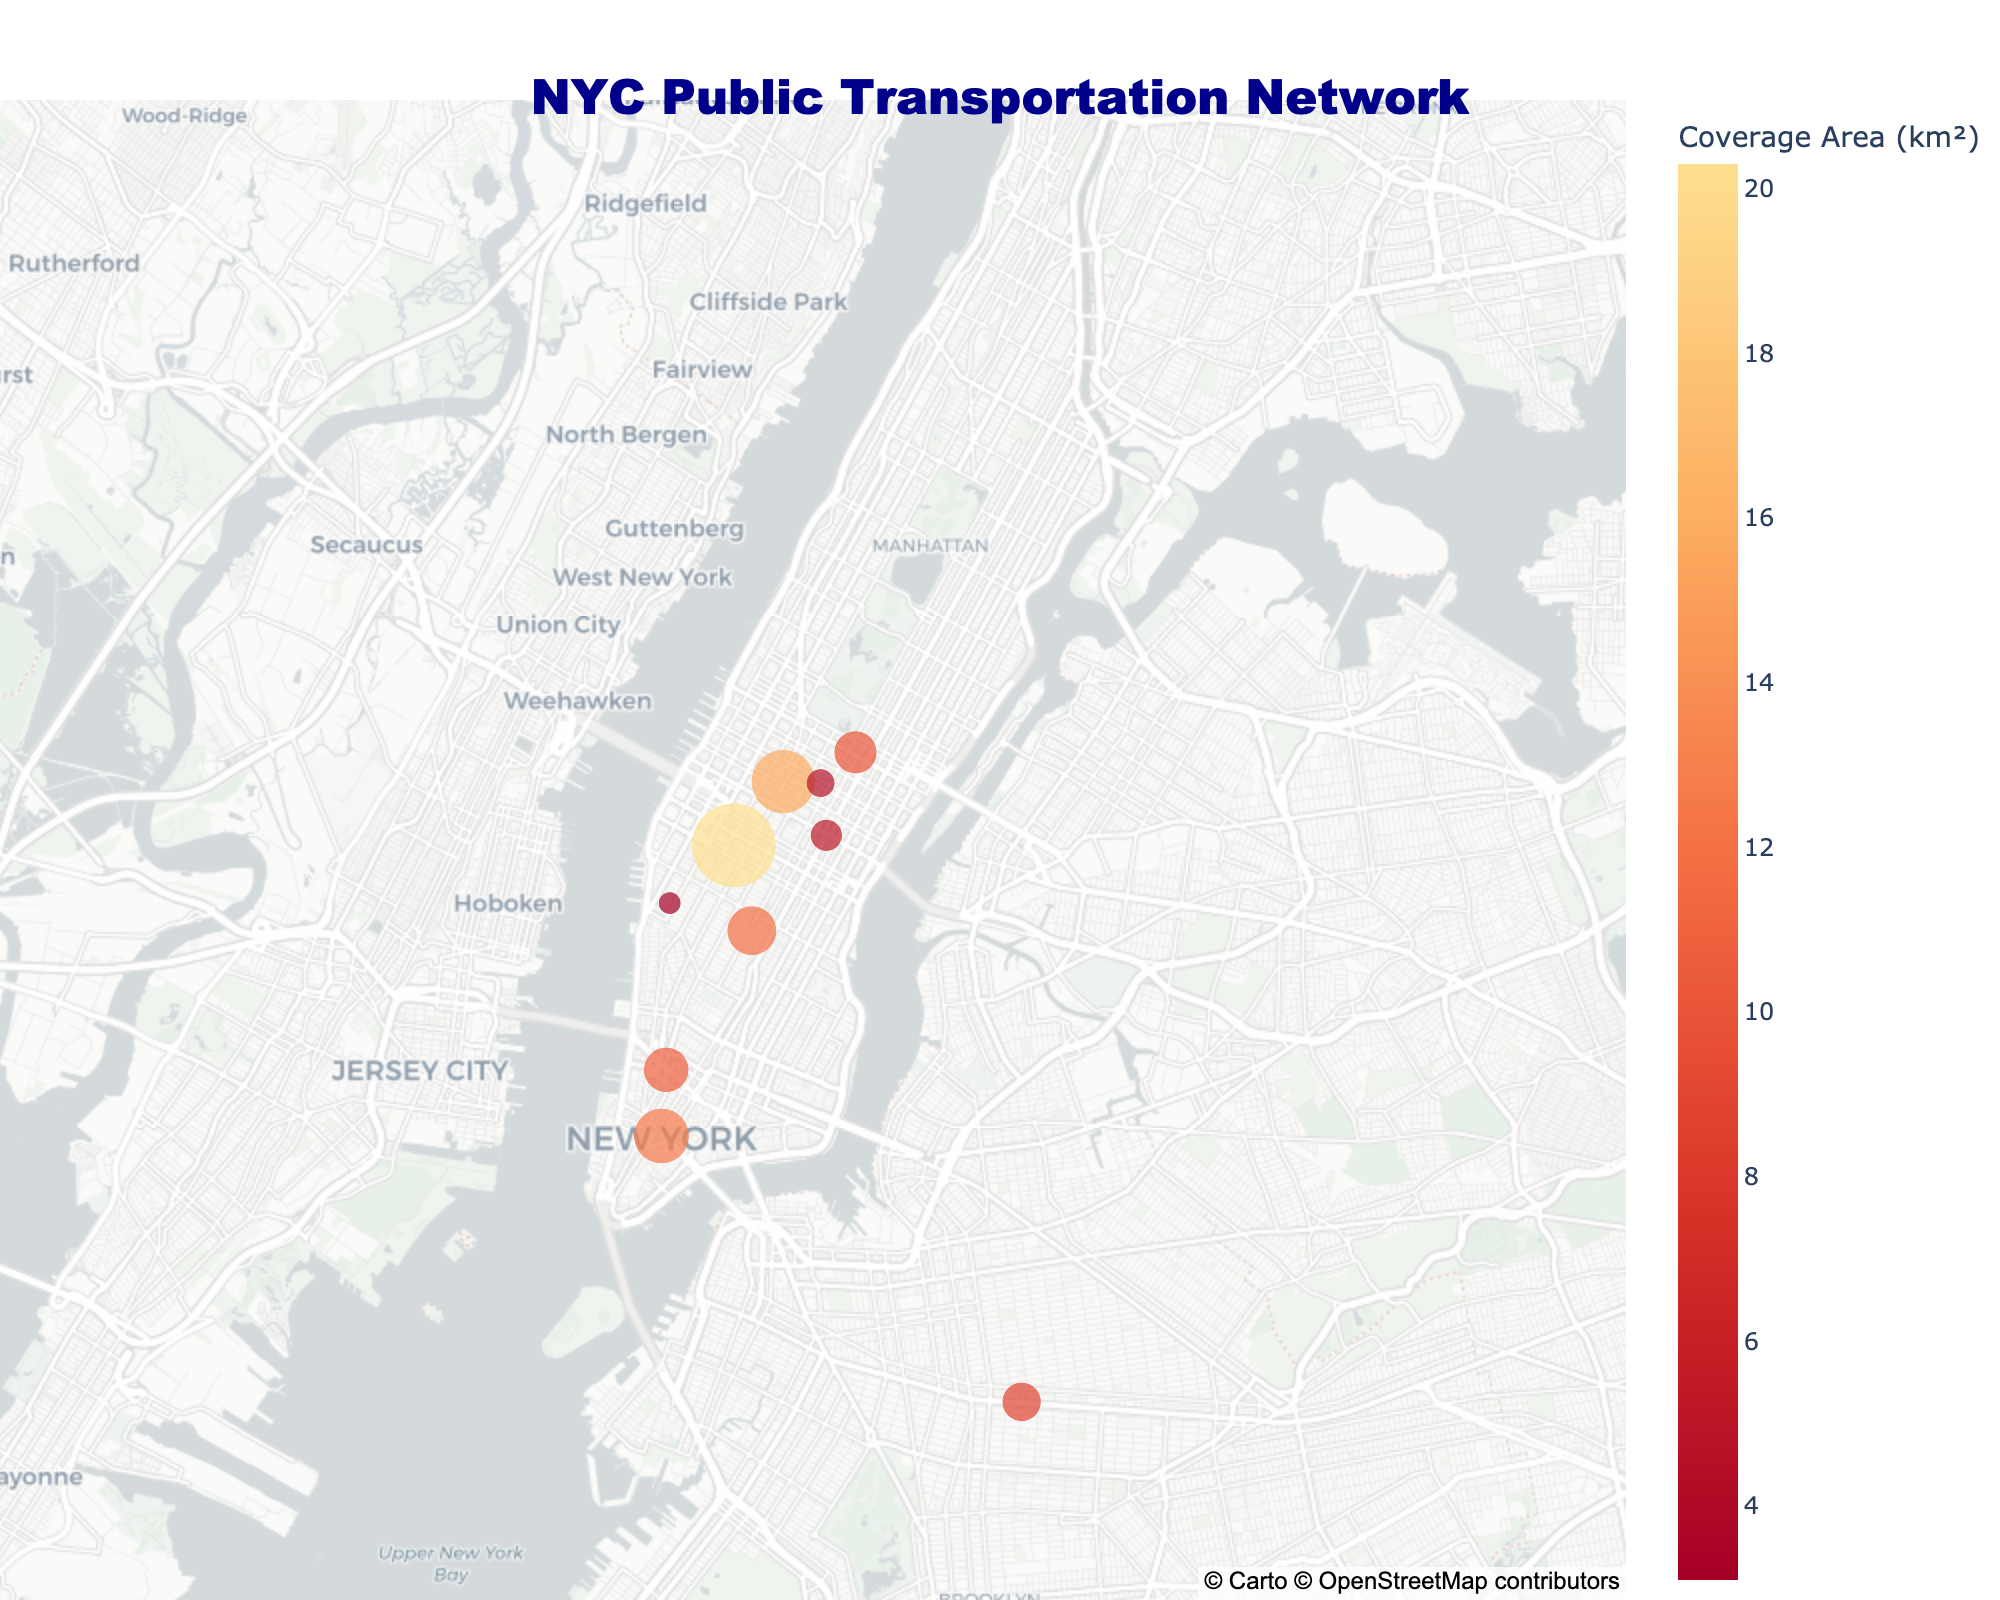How many stations are represented in the plot? Count the number of points on the map, each representing a station. There are 10 points on the map corresponding to 10 different stations.
Answer: 10 Which station has the highest daily ridership? Look for the station with the largest dot, as dot size represents daily ridership. Penn Station has the largest dot indicating a daily ridership of 350,000.
Answer: Penn Station What is the color scale representing in the plot? Refer to the colorbar which has the title indicating what it is measuring, which in this case is "Coverage Area (Km²)".
Answer: Coverage Area (Km²) Which station has the smallest coverage area and what is its value? Identify the faintest color dot on the map and refer to the hover info or the colorbar. Chelsea Piers has the smallest coverage area of 3.1 km².
Answer: Chelsea Piers, 3.1 km² Compare the daily ridership of Times Square and Atlantic Avenue-Barclays Center. Which has a higher value? Look at the size of the dots for both Times Square and Atlantic Avenue-Barclays Center, and compare. Times Square has a larger dot indicating 200,000, higher than Atlantic Avenue-Barclays Center's 75,000.
Answer: Times Square What's the total coverage area represented by all stations combined? Sum the coverage areas of all stations: 12.5 + 15.8 + 20.3 + 8.7 + 5.2 + 3.1 + 10.6 + 11.8 + 4.5 + 9.9. The total coverage area is 102.4 km².
Answer: 102.4 km² Which station's coverage area is approximately in the middle of the color scale? Look for a station with an intermediate color shade between the most intense and faint color. Times Square, with a coverage area of 15.8 km², is in the middle of the color scale.
Answer: Times Square What is the average daily ridership across all subway stations? Calculate the average of daily ridership for Grand Central, Times Square, Atlantic Avenue-Barclays Center, Union Square, and Lexington Avenue/59th Street. The average is (150,000 + 200,000 + 75,000 + 120,000 + 90,000) / 5 = 635,000 / 5 = 127,000.
Answer: 127,000 